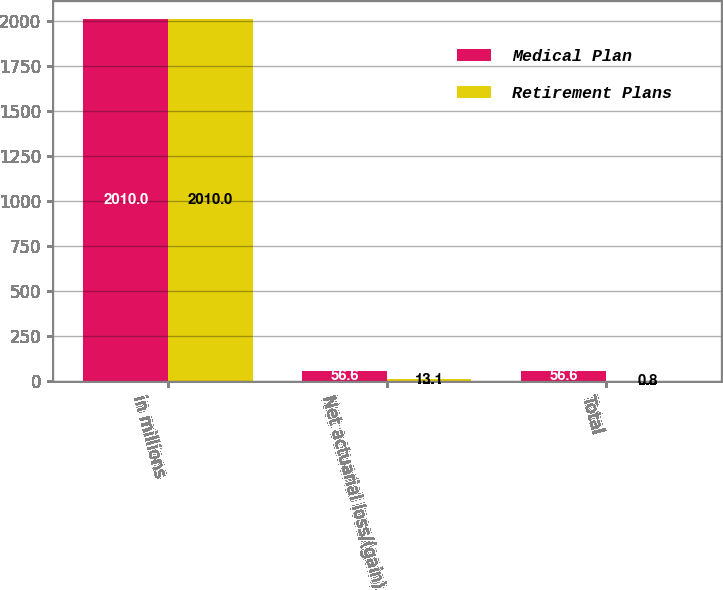<chart> <loc_0><loc_0><loc_500><loc_500><stacked_bar_chart><ecel><fcel>in millions<fcel>Net actuarial loss/(gain)<fcel>Total<nl><fcel>Medical Plan<fcel>2010<fcel>56.6<fcel>56.6<nl><fcel>Retirement Plans<fcel>2010<fcel>13.1<fcel>0.8<nl></chart> 